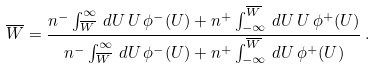<formula> <loc_0><loc_0><loc_500><loc_500>\overline { W } = \frac { n ^ { - } \int _ { \overline { W } } ^ { \infty } \, d U \, U \, \phi ^ { - } ( U ) + n ^ { + } \int _ { - \infty } ^ { \overline { W } } \, d U \, U \, \phi ^ { + } ( U ) } { n ^ { - } \int _ { \overline { W } } ^ { \infty } \, d U \, \phi ^ { - } ( U ) + n ^ { + } \int _ { - \infty } ^ { \overline { W } } \, d U \, \phi ^ { + } ( U ) } \, .</formula> 